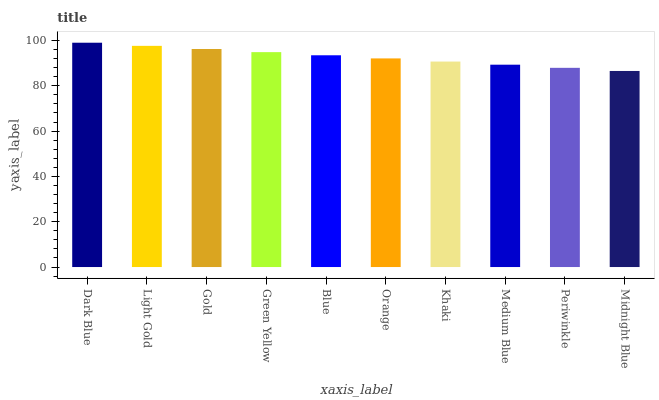Is Light Gold the minimum?
Answer yes or no. No. Is Light Gold the maximum?
Answer yes or no. No. Is Dark Blue greater than Light Gold?
Answer yes or no. Yes. Is Light Gold less than Dark Blue?
Answer yes or no. Yes. Is Light Gold greater than Dark Blue?
Answer yes or no. No. Is Dark Blue less than Light Gold?
Answer yes or no. No. Is Blue the high median?
Answer yes or no. Yes. Is Orange the low median?
Answer yes or no. Yes. Is Khaki the high median?
Answer yes or no. No. Is Gold the low median?
Answer yes or no. No. 